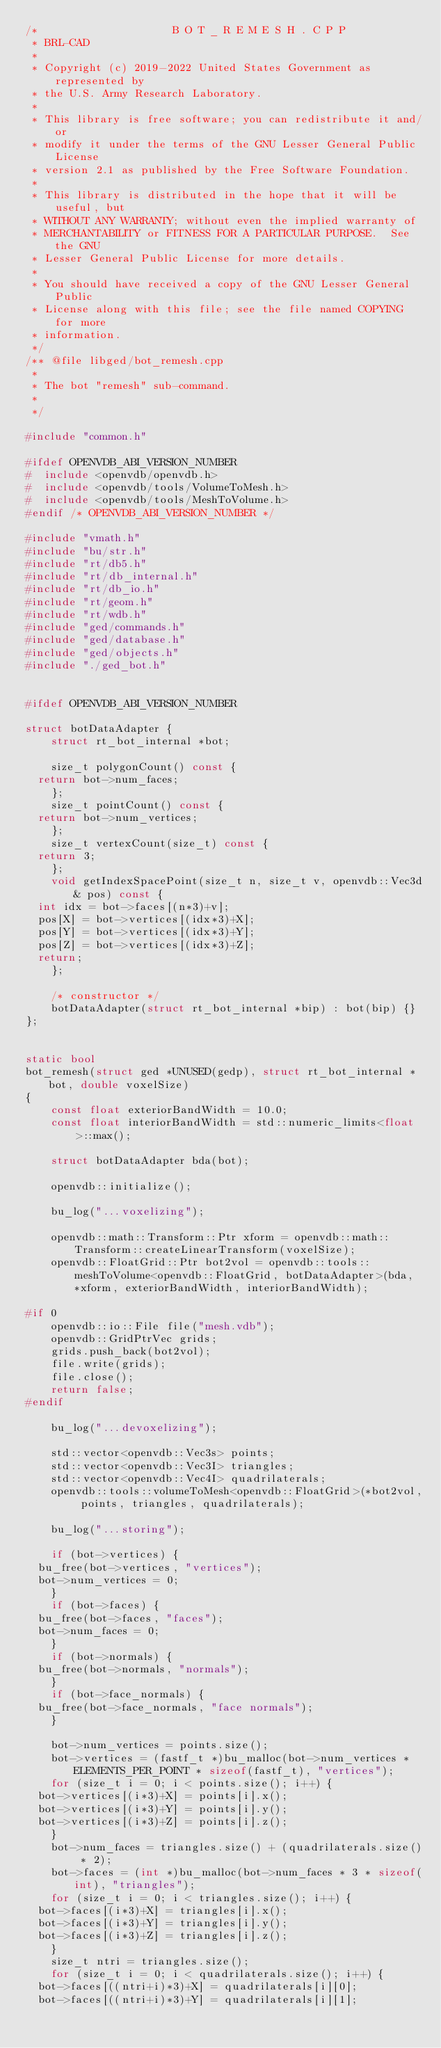Convert code to text. <code><loc_0><loc_0><loc_500><loc_500><_C++_>/*                     B O T _ R E M E S H . C P P
 * BRL-CAD
 *
 * Copyright (c) 2019-2022 United States Government as represented by
 * the U.S. Army Research Laboratory.
 *
 * This library is free software; you can redistribute it and/or
 * modify it under the terms of the GNU Lesser General Public License
 * version 2.1 as published by the Free Software Foundation.
 *
 * This library is distributed in the hope that it will be useful, but
 * WITHOUT ANY WARRANTY; without even the implied warranty of
 * MERCHANTABILITY or FITNESS FOR A PARTICULAR PURPOSE.  See the GNU
 * Lesser General Public License for more details.
 *
 * You should have received a copy of the GNU Lesser General Public
 * License along with this file; see the file named COPYING for more
 * information.
 */
/** @file libged/bot_remesh.cpp
 *
 * The bot "remesh" sub-command.
 *
 */

#include "common.h"

#ifdef OPENVDB_ABI_VERSION_NUMBER
#  include <openvdb/openvdb.h>
#  include <openvdb/tools/VolumeToMesh.h>
#  include <openvdb/tools/MeshToVolume.h>
#endif /* OPENVDB_ABI_VERSION_NUMBER */

#include "vmath.h"
#include "bu/str.h"
#include "rt/db5.h"
#include "rt/db_internal.h"
#include "rt/db_io.h"
#include "rt/geom.h"
#include "rt/wdb.h"
#include "ged/commands.h"
#include "ged/database.h"
#include "ged/objects.h"
#include "./ged_bot.h"


#ifdef OPENVDB_ABI_VERSION_NUMBER

struct botDataAdapter {
    struct rt_bot_internal *bot;

    size_t polygonCount() const {
	return bot->num_faces;
    };
    size_t pointCount() const {
	return bot->num_vertices;
    };
    size_t vertexCount(size_t) const {
	return 3;
    };
    void getIndexSpacePoint(size_t n, size_t v, openvdb::Vec3d& pos) const {
	int idx = bot->faces[(n*3)+v];
	pos[X] = bot->vertices[(idx*3)+X];
	pos[Y] = bot->vertices[(idx*3)+Y];
	pos[Z] = bot->vertices[(idx*3)+Z];
	return;
    };

    /* constructor */
    botDataAdapter(struct rt_bot_internal *bip) : bot(bip) {}
};


static bool
bot_remesh(struct ged *UNUSED(gedp), struct rt_bot_internal *bot, double voxelSize)
{
    const float exteriorBandWidth = 10.0;
    const float interiorBandWidth = std::numeric_limits<float>::max();

    struct botDataAdapter bda(bot);

    openvdb::initialize();

    bu_log("...voxelizing");

    openvdb::math::Transform::Ptr xform = openvdb::math::Transform::createLinearTransform(voxelSize);
    openvdb::FloatGrid::Ptr bot2vol = openvdb::tools::meshToVolume<openvdb::FloatGrid, botDataAdapter>(bda, *xform, exteriorBandWidth, interiorBandWidth);

#if 0
    openvdb::io::File file("mesh.vdb");
    openvdb::GridPtrVec grids;
    grids.push_back(bot2vol);
    file.write(grids);
    file.close();
    return false;
#endif

    bu_log("...devoxelizing");

    std::vector<openvdb::Vec3s> points;
    std::vector<openvdb::Vec3I> triangles;
    std::vector<openvdb::Vec4I> quadrilaterals;
    openvdb::tools::volumeToMesh<openvdb::FloatGrid>(*bot2vol, points, triangles, quadrilaterals);

    bu_log("...storing");

    if (bot->vertices) {
	bu_free(bot->vertices, "vertices");
	bot->num_vertices = 0;
    }
    if (bot->faces) {
	bu_free(bot->faces, "faces");
	bot->num_faces = 0;
    }
    if (bot->normals) {
	bu_free(bot->normals, "normals");
    }
    if (bot->face_normals) {
	bu_free(bot->face_normals, "face normals");
    }

    bot->num_vertices = points.size();
    bot->vertices = (fastf_t *)bu_malloc(bot->num_vertices * ELEMENTS_PER_POINT * sizeof(fastf_t), "vertices");
    for (size_t i = 0; i < points.size(); i++) {
	bot->vertices[(i*3)+X] = points[i].x();
	bot->vertices[(i*3)+Y] = points[i].y();
	bot->vertices[(i*3)+Z] = points[i].z();
    }
    bot->num_faces = triangles.size() + (quadrilaterals.size() * 2);
    bot->faces = (int *)bu_malloc(bot->num_faces * 3 * sizeof(int), "triangles");
    for (size_t i = 0; i < triangles.size(); i++) {
	bot->faces[(i*3)+X] = triangles[i].x();
	bot->faces[(i*3)+Y] = triangles[i].y();
	bot->faces[(i*3)+Z] = triangles[i].z();
    }
    size_t ntri = triangles.size();
    for (size_t i = 0; i < quadrilaterals.size(); i++) {
	bot->faces[((ntri+i)*3)+X] = quadrilaterals[i][0];
	bot->faces[((ntri+i)*3)+Y] = quadrilaterals[i][1];</code> 